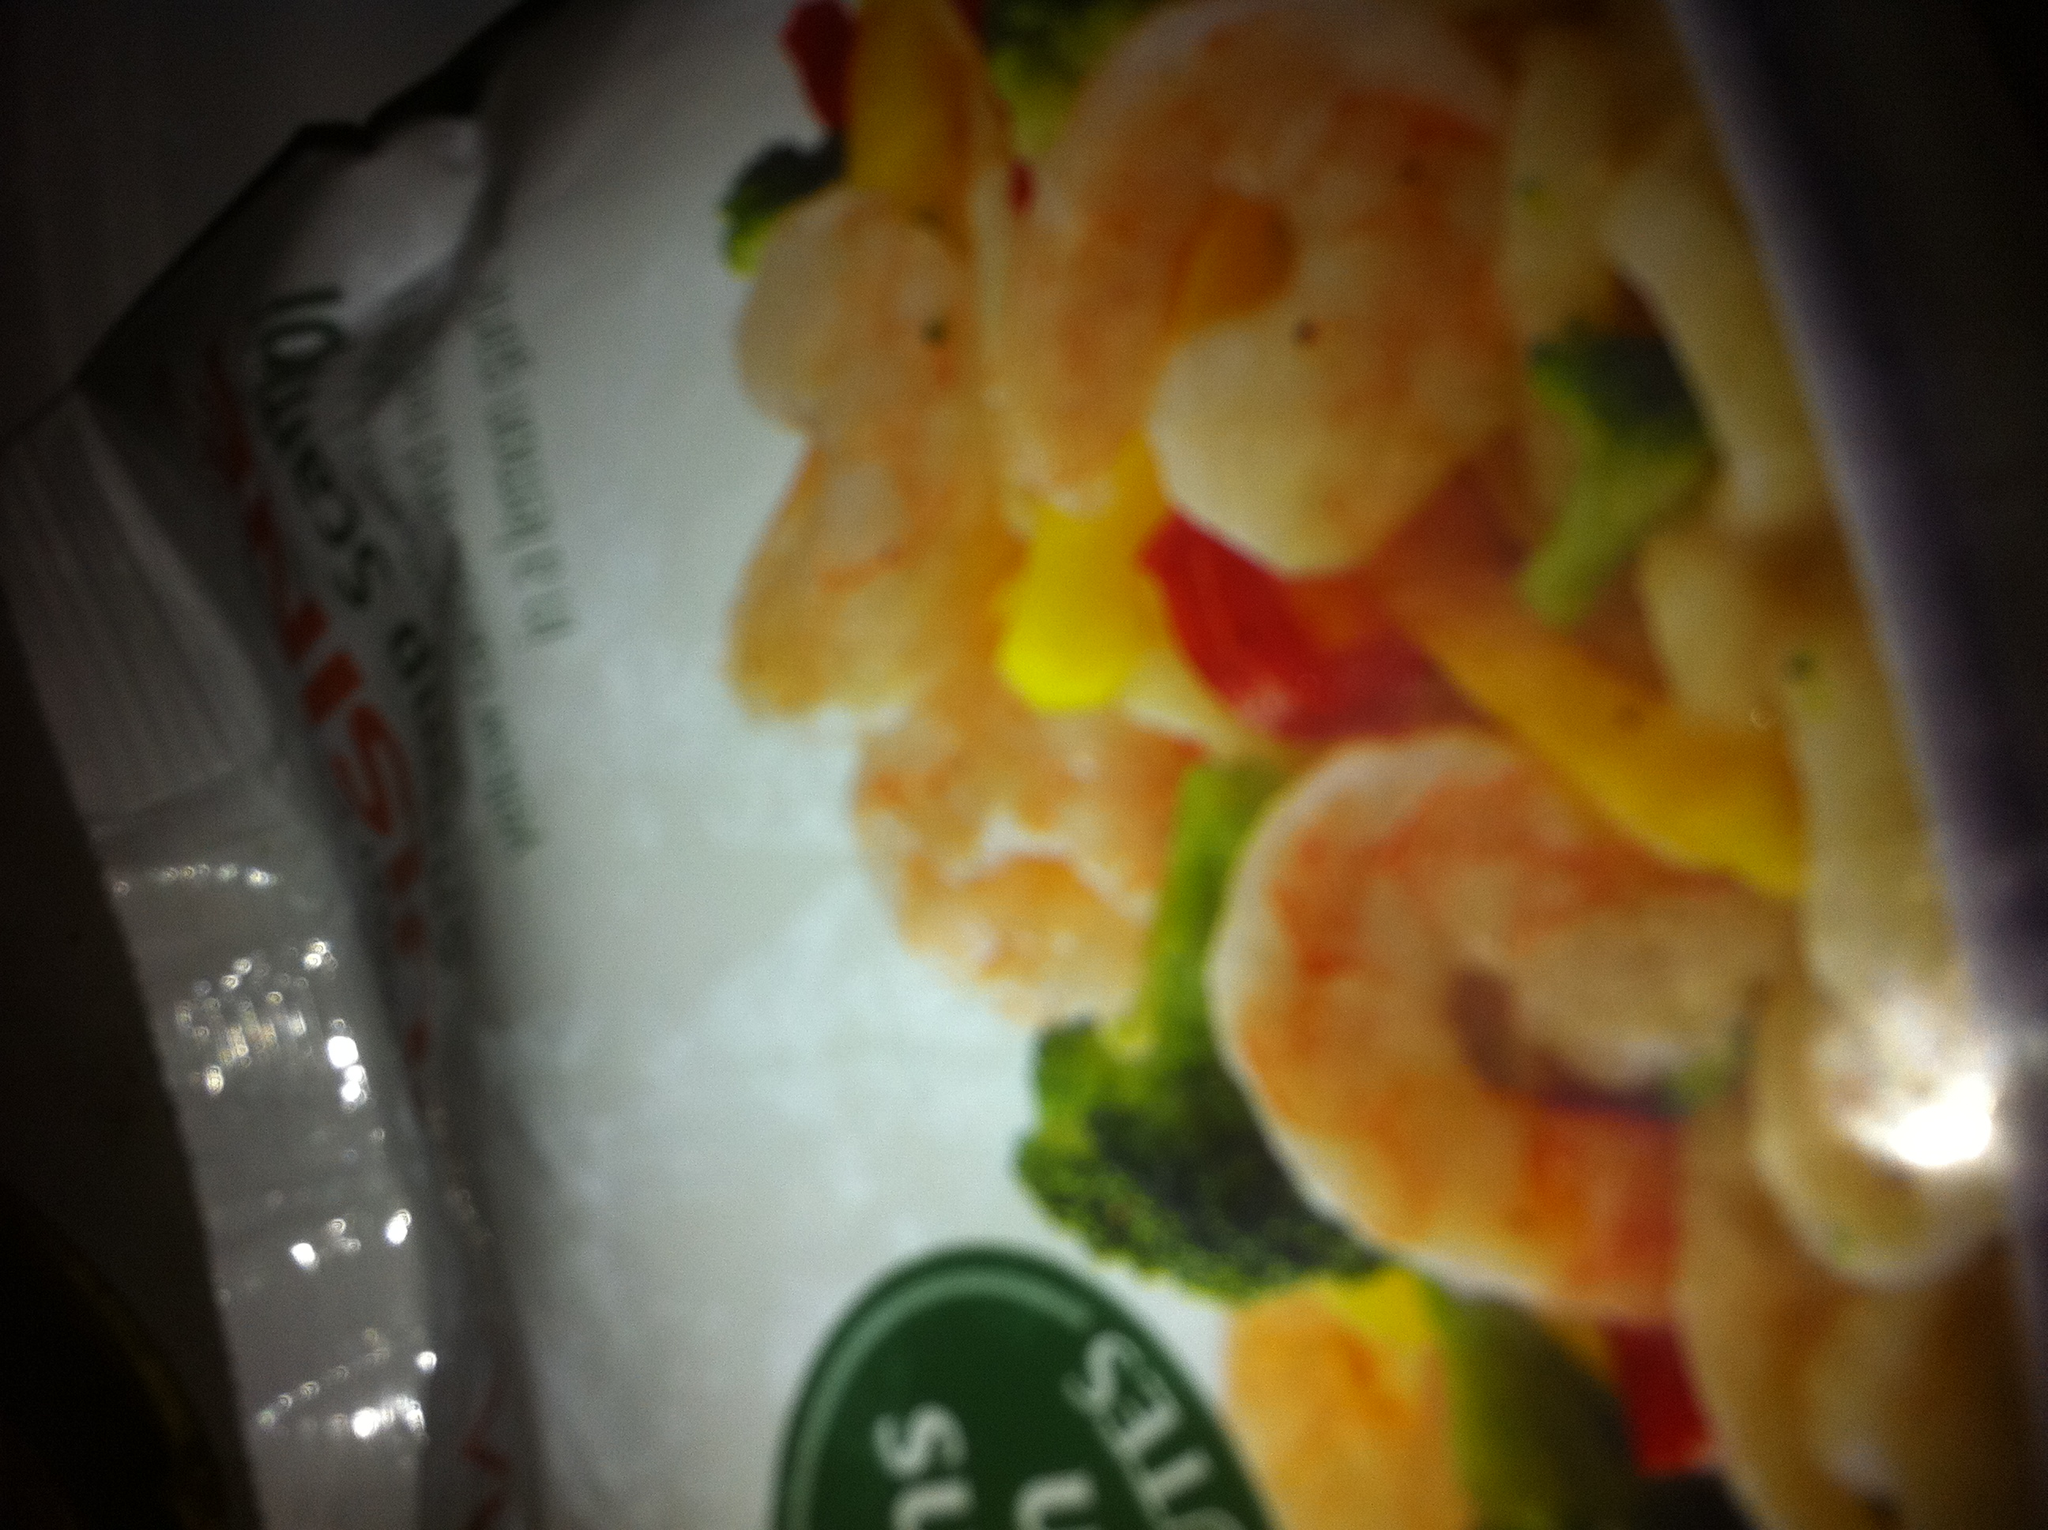What are some similar meal options that focus on health and convenience? Similar meal options include chicken and vegetable stir-fry, quinoa bowls with mixed veggies and tofu, and salmon with steamed greens. These meals also emphasize quick preparation and nutritional balance, making them excellent choices for health-conscious individuals with busy schedules. 